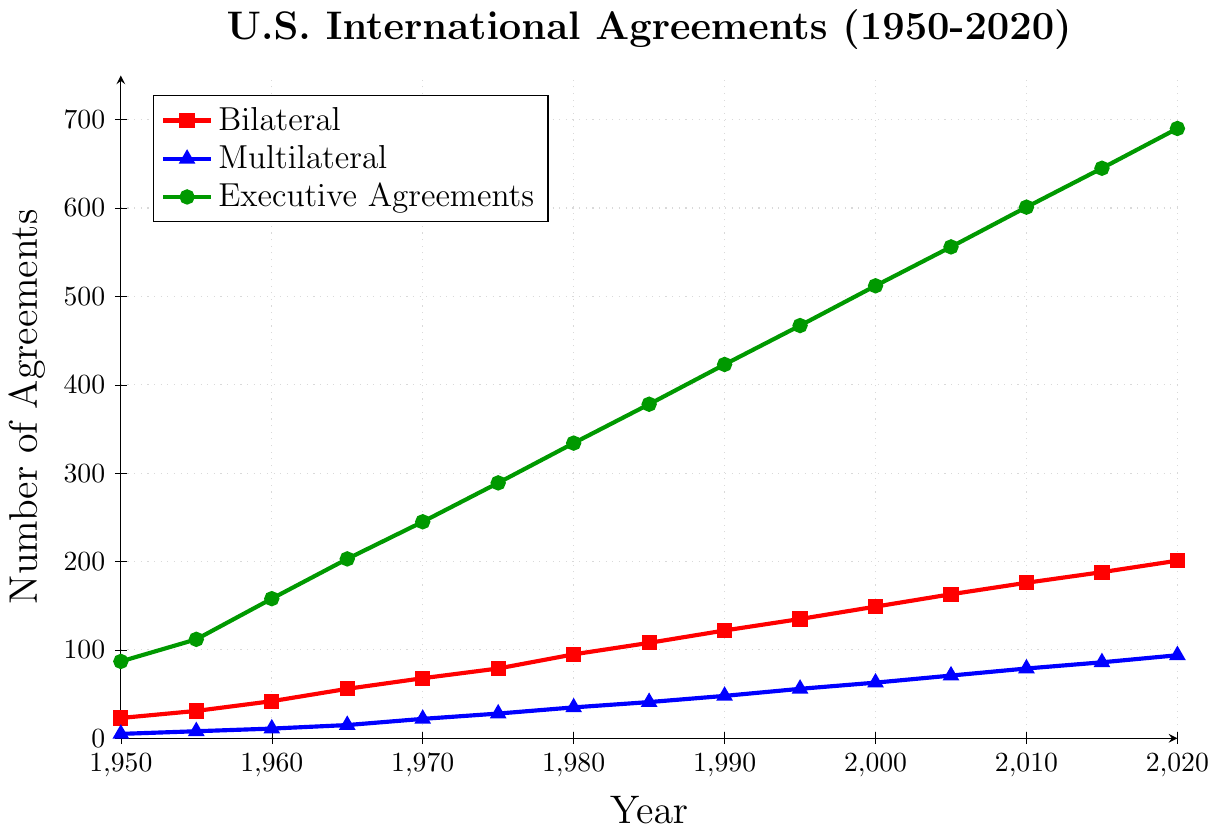What is the highest number of bilateral agreements signed? The highest number of bilateral agreements is shown at the end of the time series on the plot. In the year 2020, the number of bilateral agreements is 201.
Answer: 201 Which year had the greatest increase in the number of executive agreements compared to the previous year? To determine the greatest increase, subtract the number of executive agreements in each year from the previous year and find the maximum difference. Notable increases can be easily seen between consecutive data points on the plot. The largest jump appears to be from 1965 to 1970 (245 - 203 = 42).
Answer: 1970 What is the difference between the number of executive agreements and multilateral agreements in 2005? For 2005, the number of executive agreements is 556 and the number of multilateral agreements is 71. Subtract the latter from the former: 556 - 71 = 485.
Answer: 485 How many types of agreements are shown in the figure? The figure uses three different colors/shapes to represent three types of agreements: bilateral, multilateral, and executive agreements. By looking at the legend, we can confirm the types.
Answer: 3 In which year did the number of bilateral agreements first exceed 100? By inspecting the red line with square marks, the number exceeds 100 between 1980 and 1985. In 1985, the number of bilateral agreements is 108, which is over 100.
Answer: 1985 Compare the number of multilateral agreements in 1965 to the number in 1985. Which is higher? The blue line with triangle marks represents multilateral agreements. In 1965, the number is 15, and in 1985, it is 41. 41 is greater than 15.
Answer: 1985 What is the total number of agreements signed in 1970 for all categories? Sum the bilateral, multilateral, and executive agreements in 1970: 68 (bilateral) + 22 (multilateral) + 245 (executive) = 335.
Answer: 335 What is the average number of multilateral agreements signed per year from 2000 to 2020? First, find the number of multilateral agreements for each year: 63 (2000), 71 (2005), 79 (2010), 86 (2015), and 94 (2020). Next, sum these figures: 63 + 71 + 79 + 86 + 94 = 393. There are 5 data points, so the average is 393 / 5 = 78.6.
Answer: 78.6 By how much did the number of bilateral agreements change from 1950 to 2000? The number of bilateral agreements in 1950 is 23, and in 2000 it is 149. The change is calculated by 149 - 23 = 126.
Answer: 126 